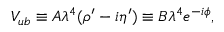<formula> <loc_0><loc_0><loc_500><loc_500>V _ { u b } \equiv A \lambda ^ { 4 } ( \rho ^ { \prime } - i \eta ^ { \prime } ) \equiv B \lambda ^ { 4 } e ^ { - i \phi } ,</formula> 